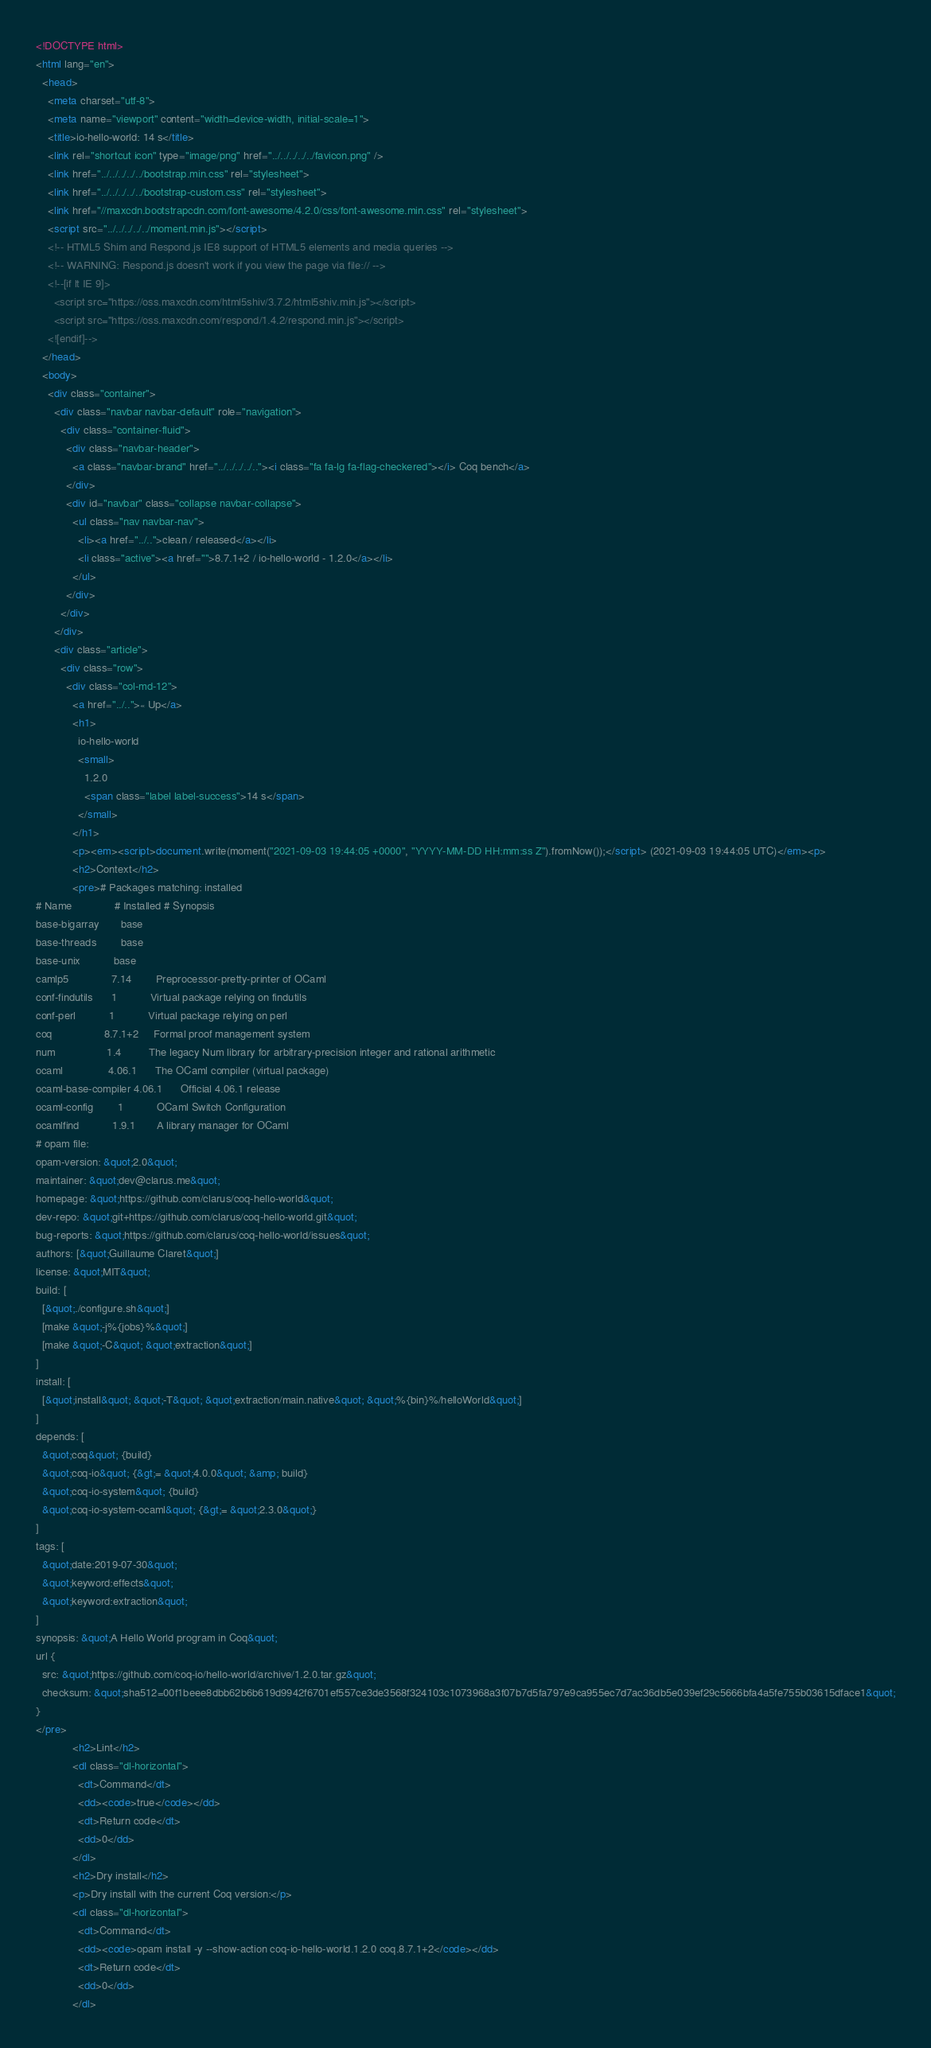Convert code to text. <code><loc_0><loc_0><loc_500><loc_500><_HTML_><!DOCTYPE html>
<html lang="en">
  <head>
    <meta charset="utf-8">
    <meta name="viewport" content="width=device-width, initial-scale=1">
    <title>io-hello-world: 14 s</title>
    <link rel="shortcut icon" type="image/png" href="../../../../../favicon.png" />
    <link href="../../../../../bootstrap.min.css" rel="stylesheet">
    <link href="../../../../../bootstrap-custom.css" rel="stylesheet">
    <link href="//maxcdn.bootstrapcdn.com/font-awesome/4.2.0/css/font-awesome.min.css" rel="stylesheet">
    <script src="../../../../../moment.min.js"></script>
    <!-- HTML5 Shim and Respond.js IE8 support of HTML5 elements and media queries -->
    <!-- WARNING: Respond.js doesn't work if you view the page via file:// -->
    <!--[if lt IE 9]>
      <script src="https://oss.maxcdn.com/html5shiv/3.7.2/html5shiv.min.js"></script>
      <script src="https://oss.maxcdn.com/respond/1.4.2/respond.min.js"></script>
    <![endif]-->
  </head>
  <body>
    <div class="container">
      <div class="navbar navbar-default" role="navigation">
        <div class="container-fluid">
          <div class="navbar-header">
            <a class="navbar-brand" href="../../../../.."><i class="fa fa-lg fa-flag-checkered"></i> Coq bench</a>
          </div>
          <div id="navbar" class="collapse navbar-collapse">
            <ul class="nav navbar-nav">
              <li><a href="../..">clean / released</a></li>
              <li class="active"><a href="">8.7.1+2 / io-hello-world - 1.2.0</a></li>
            </ul>
          </div>
        </div>
      </div>
      <div class="article">
        <div class="row">
          <div class="col-md-12">
            <a href="../..">« Up</a>
            <h1>
              io-hello-world
              <small>
                1.2.0
                <span class="label label-success">14 s</span>
              </small>
            </h1>
            <p><em><script>document.write(moment("2021-09-03 19:44:05 +0000", "YYYY-MM-DD HH:mm:ss Z").fromNow());</script> (2021-09-03 19:44:05 UTC)</em><p>
            <h2>Context</h2>
            <pre># Packages matching: installed
# Name              # Installed # Synopsis
base-bigarray       base
base-threads        base
base-unix           base
camlp5              7.14        Preprocessor-pretty-printer of OCaml
conf-findutils      1           Virtual package relying on findutils
conf-perl           1           Virtual package relying on perl
coq                 8.7.1+2     Formal proof management system
num                 1.4         The legacy Num library for arbitrary-precision integer and rational arithmetic
ocaml               4.06.1      The OCaml compiler (virtual package)
ocaml-base-compiler 4.06.1      Official 4.06.1 release
ocaml-config        1           OCaml Switch Configuration
ocamlfind           1.9.1       A library manager for OCaml
# opam file:
opam-version: &quot;2.0&quot;
maintainer: &quot;dev@clarus.me&quot;
homepage: &quot;https://github.com/clarus/coq-hello-world&quot;
dev-repo: &quot;git+https://github.com/clarus/coq-hello-world.git&quot;
bug-reports: &quot;https://github.com/clarus/coq-hello-world/issues&quot;
authors: [&quot;Guillaume Claret&quot;]
license: &quot;MIT&quot;
build: [
  [&quot;./configure.sh&quot;]
  [make &quot;-j%{jobs}%&quot;]
  [make &quot;-C&quot; &quot;extraction&quot;]
]
install: [
  [&quot;install&quot; &quot;-T&quot; &quot;extraction/main.native&quot; &quot;%{bin}%/helloWorld&quot;]
]
depends: [
  &quot;coq&quot; {build}
  &quot;coq-io&quot; {&gt;= &quot;4.0.0&quot; &amp; build}
  &quot;coq-io-system&quot; {build}
  &quot;coq-io-system-ocaml&quot; {&gt;= &quot;2.3.0&quot;}
]
tags: [
  &quot;date:2019-07-30&quot;
  &quot;keyword:effects&quot;
  &quot;keyword:extraction&quot;
]
synopsis: &quot;A Hello World program in Coq&quot;
url {
  src: &quot;https://github.com/coq-io/hello-world/archive/1.2.0.tar.gz&quot;
  checksum: &quot;sha512=00f1beee8dbb62b6b619d9942f6701ef557ce3de3568f324103c1073968a3f07b7d5fa797e9ca955ec7d7ac36db5e039ef29c5666bfa4a5fe755b03615dface1&quot;
}
</pre>
            <h2>Lint</h2>
            <dl class="dl-horizontal">
              <dt>Command</dt>
              <dd><code>true</code></dd>
              <dt>Return code</dt>
              <dd>0</dd>
            </dl>
            <h2>Dry install</h2>
            <p>Dry install with the current Coq version:</p>
            <dl class="dl-horizontal">
              <dt>Command</dt>
              <dd><code>opam install -y --show-action coq-io-hello-world.1.2.0 coq.8.7.1+2</code></dd>
              <dt>Return code</dt>
              <dd>0</dd>
            </dl></code> 